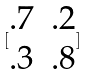Convert formula to latex. <formula><loc_0><loc_0><loc_500><loc_500>[ \begin{matrix} . 7 & . 2 \\ . 3 & . 8 \end{matrix} ]</formula> 